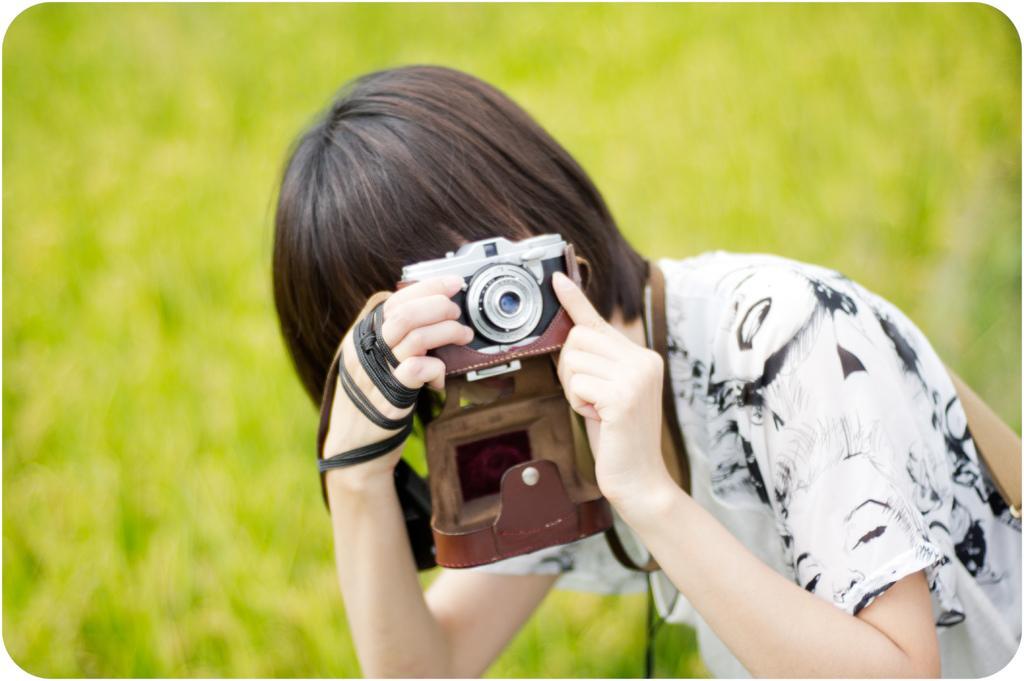Describe this image in one or two sentences. Background portion of the picture is green in color and it's blurry. Here we can see a person holding a camera in the hands. This person wore a black and white t-shirt. 